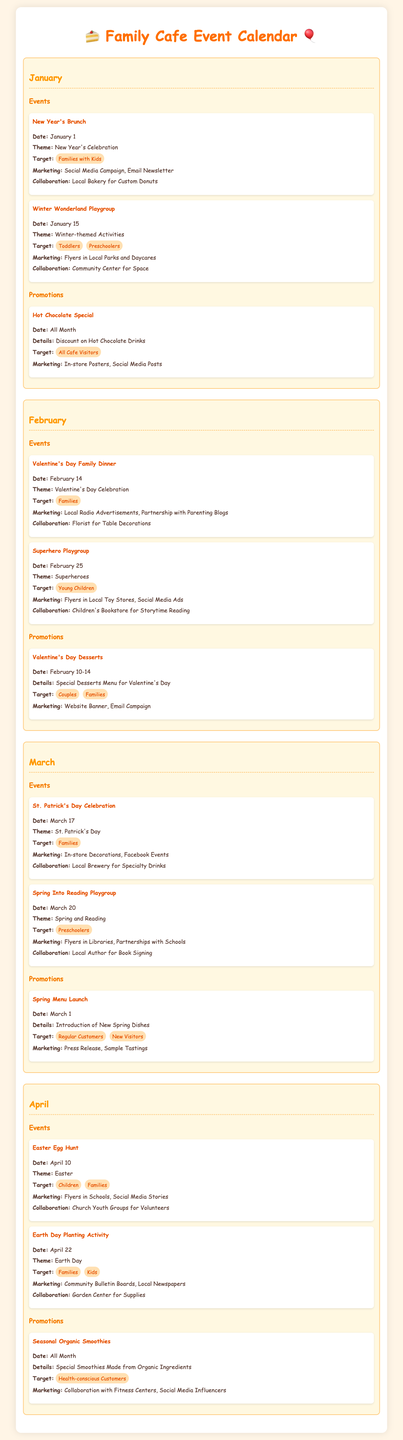What is the theme of the New Year's Brunch? The theme of the New Year's Brunch is specified in the document as "New Year's Celebration."
Answer: New Year's Celebration When is the Valentine's Day Family Dinner scheduled? The date for the Valentine's Day Family Dinner is explicitly stated in the document as February 14.
Answer: February 14 Who is collaborating for the Easter Egg Hunt event? The document mentions that Church Youth Groups are collaborating for the Easter Egg Hunt event.
Answer: Church Youth Groups What is the target audience for the Spring Into Reading Playgroup? The document lists "Preschoolers" as the target audience for the Spring Into Reading Playgroup.
Answer: Preschoolers Which promotional item is available all month in April? The document states that "Seasonal Organic Smoothies" are available all month in April.
Answer: Seasonal Organic Smoothies How many events are scheduled in February? By counting the events listed in February, there are two events scheduled for that month.
Answer: 2 What marketing strategy is used for the Valentine's Day Desserts promotion? The document identifies "Website Banner, Email Campaign" as the marketing strategy for the Valentine's Day Desserts promotion.
Answer: Website Banner, Email Campaign What is the special offer in January? The special offer in January is described as a discount on Hot Chocolate Drinks in the document.
Answer: Discount on Hot Chocolate Drinks Which event is on March 20? The event scheduled for March 20 is the "Spring Into Reading Playgroup."
Answer: Spring Into Reading Playgroup 